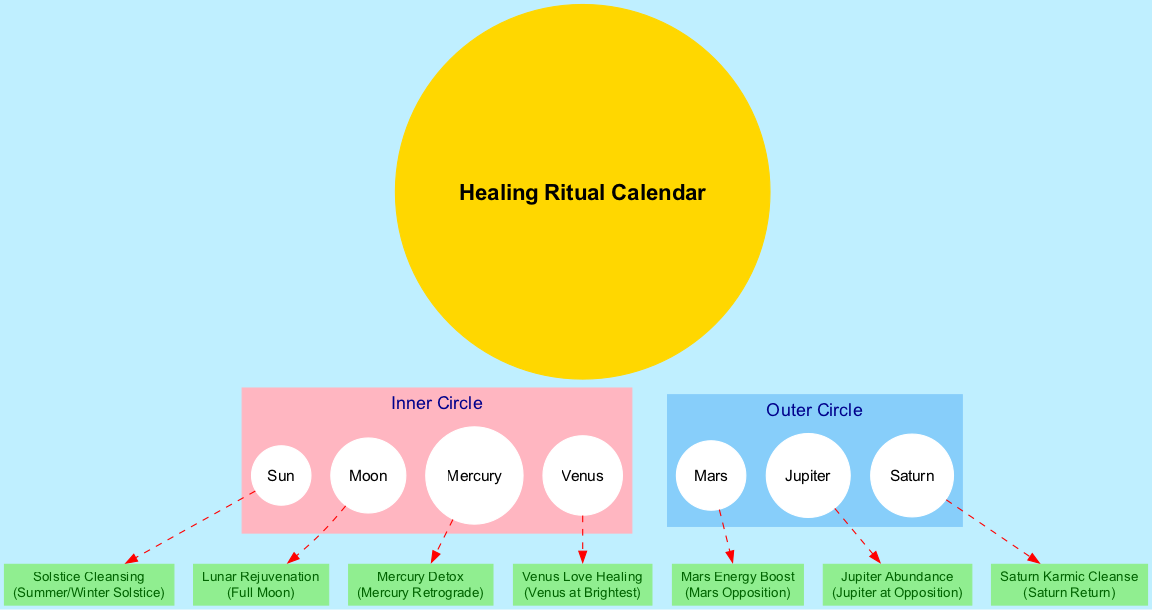What is at the center of the diagram? The center node of the diagram is labeled "Healing Ritual Calendar." It serves as the main focus of the diagram and all other nodes orbit around it.
Answer: Healing Ritual Calendar How many celestial bodies are listed in the Inner Circle? The Inner Circle has four celestial bodies: Sun, Moon, Mercury, and Venus. By counting these bodies, we determine the total number.
Answer: 4 What is the timing of the "Mars Energy Boost" ritual? The ritual "Mars Energy Boost" is specifically listed to occur during "Mars Opposition." This is clearly indicated in the associated information for that ritual.
Answer: Mars Opposition Which celestial body is associated with "Lunar Rejuvenation"? The "Lunar Rejuvenation" ritual is specifically associated with the "Moon." This is evident from the label indicating the celestial body related to the ritual.
Answer: Moon What color represents the Outer Circle in the diagram? The Outer Circle is represented with the color "lightskyblue." This information is derived from the attributes set in the diagram for the orbit clusters.
Answer: lightskyblue How many rituals are associated with the Sun? There is one ritual associated with the Sun, which is "Solstice Cleansing." By examining the rituals listed and their corresponding celestial bodies, we can conclude the count.
Answer: 1 Which ritual is associated with Venus? The ritual connected to Venus is "Venus Love Healing." This can be identified by looking at the rituals and finding the one linked to the Venus celestial body.
Answer: Venus Love Healing During which event does the "Saturn Karmic Cleanse" take place? The "Saturn Karmic Cleanse" ritual occurs during a "Saturn Return." This information is directly accompanying the ritual in the diagram.
Answer: Saturn Return Which celestial body represents the ritual "Jupiter Abundance"? "Jupiter Abundance" is represented by the celestial body "Jupiter." By checking the rituals and their corresponding celestial bodies in the diagram, we can identify this.
Answer: Jupiter 